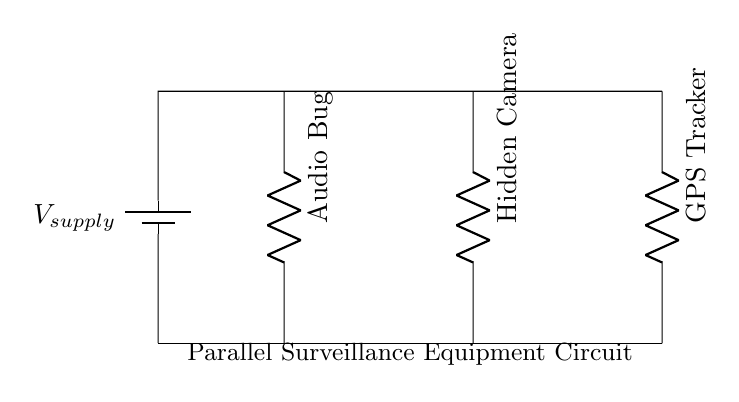What components are included in this circuit? The circuit includes three components: an audio bug, a hidden camera, and a GPS tracker. These are the main devices connected in parallel for surveillance.
Answer: audio bug, hidden camera, GPS tracker What is the configuration type of this circuit? The circuit is arranged such that all devices are connected in parallel. In a parallel configuration, each component is connected across the same voltage supply.
Answer: parallel What is the function of the battery in this circuit? The battery provides the necessary voltage supply for the components connected in the circuit. It ensures that each device receives power to operate independently.
Answer: power supply How many parallel branches are there in the circuit? There are three parallel branches, one for each component: the audio bug, hidden camera, and GPS tracker. Each branch operates independently while sharing the same supply voltage.
Answer: three If one component fails, what happens to the others? If one component fails, the other components will continue to function normally. This is a key advantage of parallel circuits, as they allow for the isolation of components.
Answer: continue to function What is the role of the resistors in this circuit? The resistors, represented by the labels, likely serve to manage the current flowing through each component, ensuring that each device operates within its safe limits.
Answer: current management 